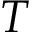<formula> <loc_0><loc_0><loc_500><loc_500>T</formula> 